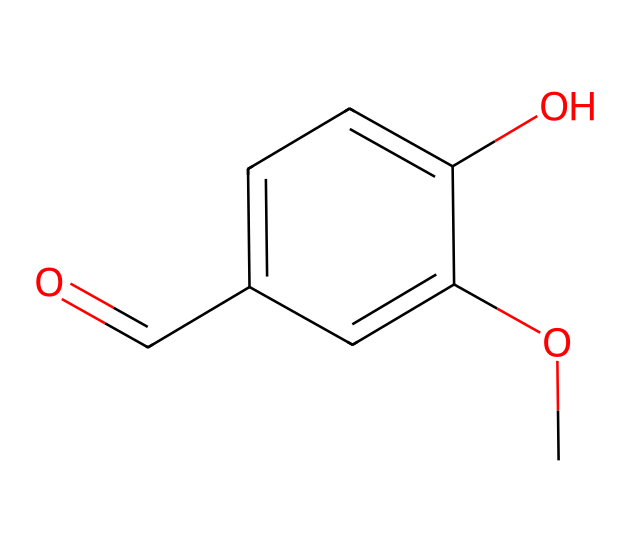How many carbon atoms are present in the chemical structure? By analyzing the SMILES representation, we can note that there are five carbon atoms (C) in the aromatic ring and one carbon in the carbonyl group, totaling six carbon atoms.
Answer: six What type of functional group is present in vanillin? In the chemical structure, the carbonyl group (C=O) linked to the aromatic ring indicates the presence of an aldehyde functional group, which is characteristic of vanillin.
Answer: aldehyde What does the "O" in the SMILES represent in terms of functionality? The "O" in the SMILES indicates the presence of an oxygen atom, which is part of the methoxy group (–OCH3) and the hydroxyl group (–OH), both contributing to the flavor profile of vanillin.
Answer: methoxy and hydroxyl How many hydroxyl groups are there in this molecule? Examining the structure reveals there is one hydroxyl group (-OH) attached to the aromatic ring, contributing to its flavor characteristics; therefore, the answer is one.
Answer: one Which part of this chemical contributes to its sweet flavor? The methoxy group (-OCH3) and the hydroxyl group (-OH) enhance the sweetness of vanillin, making it palatable and aromatic.
Answer: methoxy and hydroxyl What is the overall molecular formula derived from this structure? From the interpretation of the SMILES notation, we can deduce the molecular formula to be C8H8O3, calculated from the count of carbon, hydrogen, and oxygen atoms depicted in the structure.
Answer: C8H8O3 